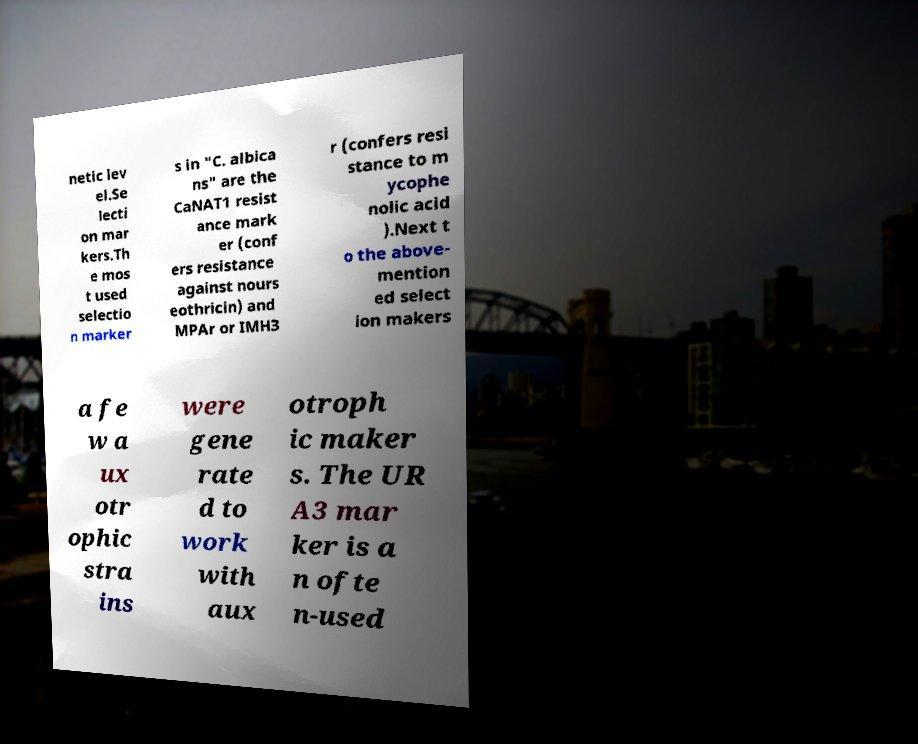Can you accurately transcribe the text from the provided image for me? netic lev el.Se lecti on mar kers.Th e mos t used selectio n marker s in "C. albica ns" are the CaNAT1 resist ance mark er (conf ers resistance against nours eothricin) and MPAr or IMH3 r (confers resi stance to m ycophe nolic acid ).Next t o the above- mention ed select ion makers a fe w a ux otr ophic stra ins were gene rate d to work with aux otroph ic maker s. The UR A3 mar ker is a n ofte n-used 